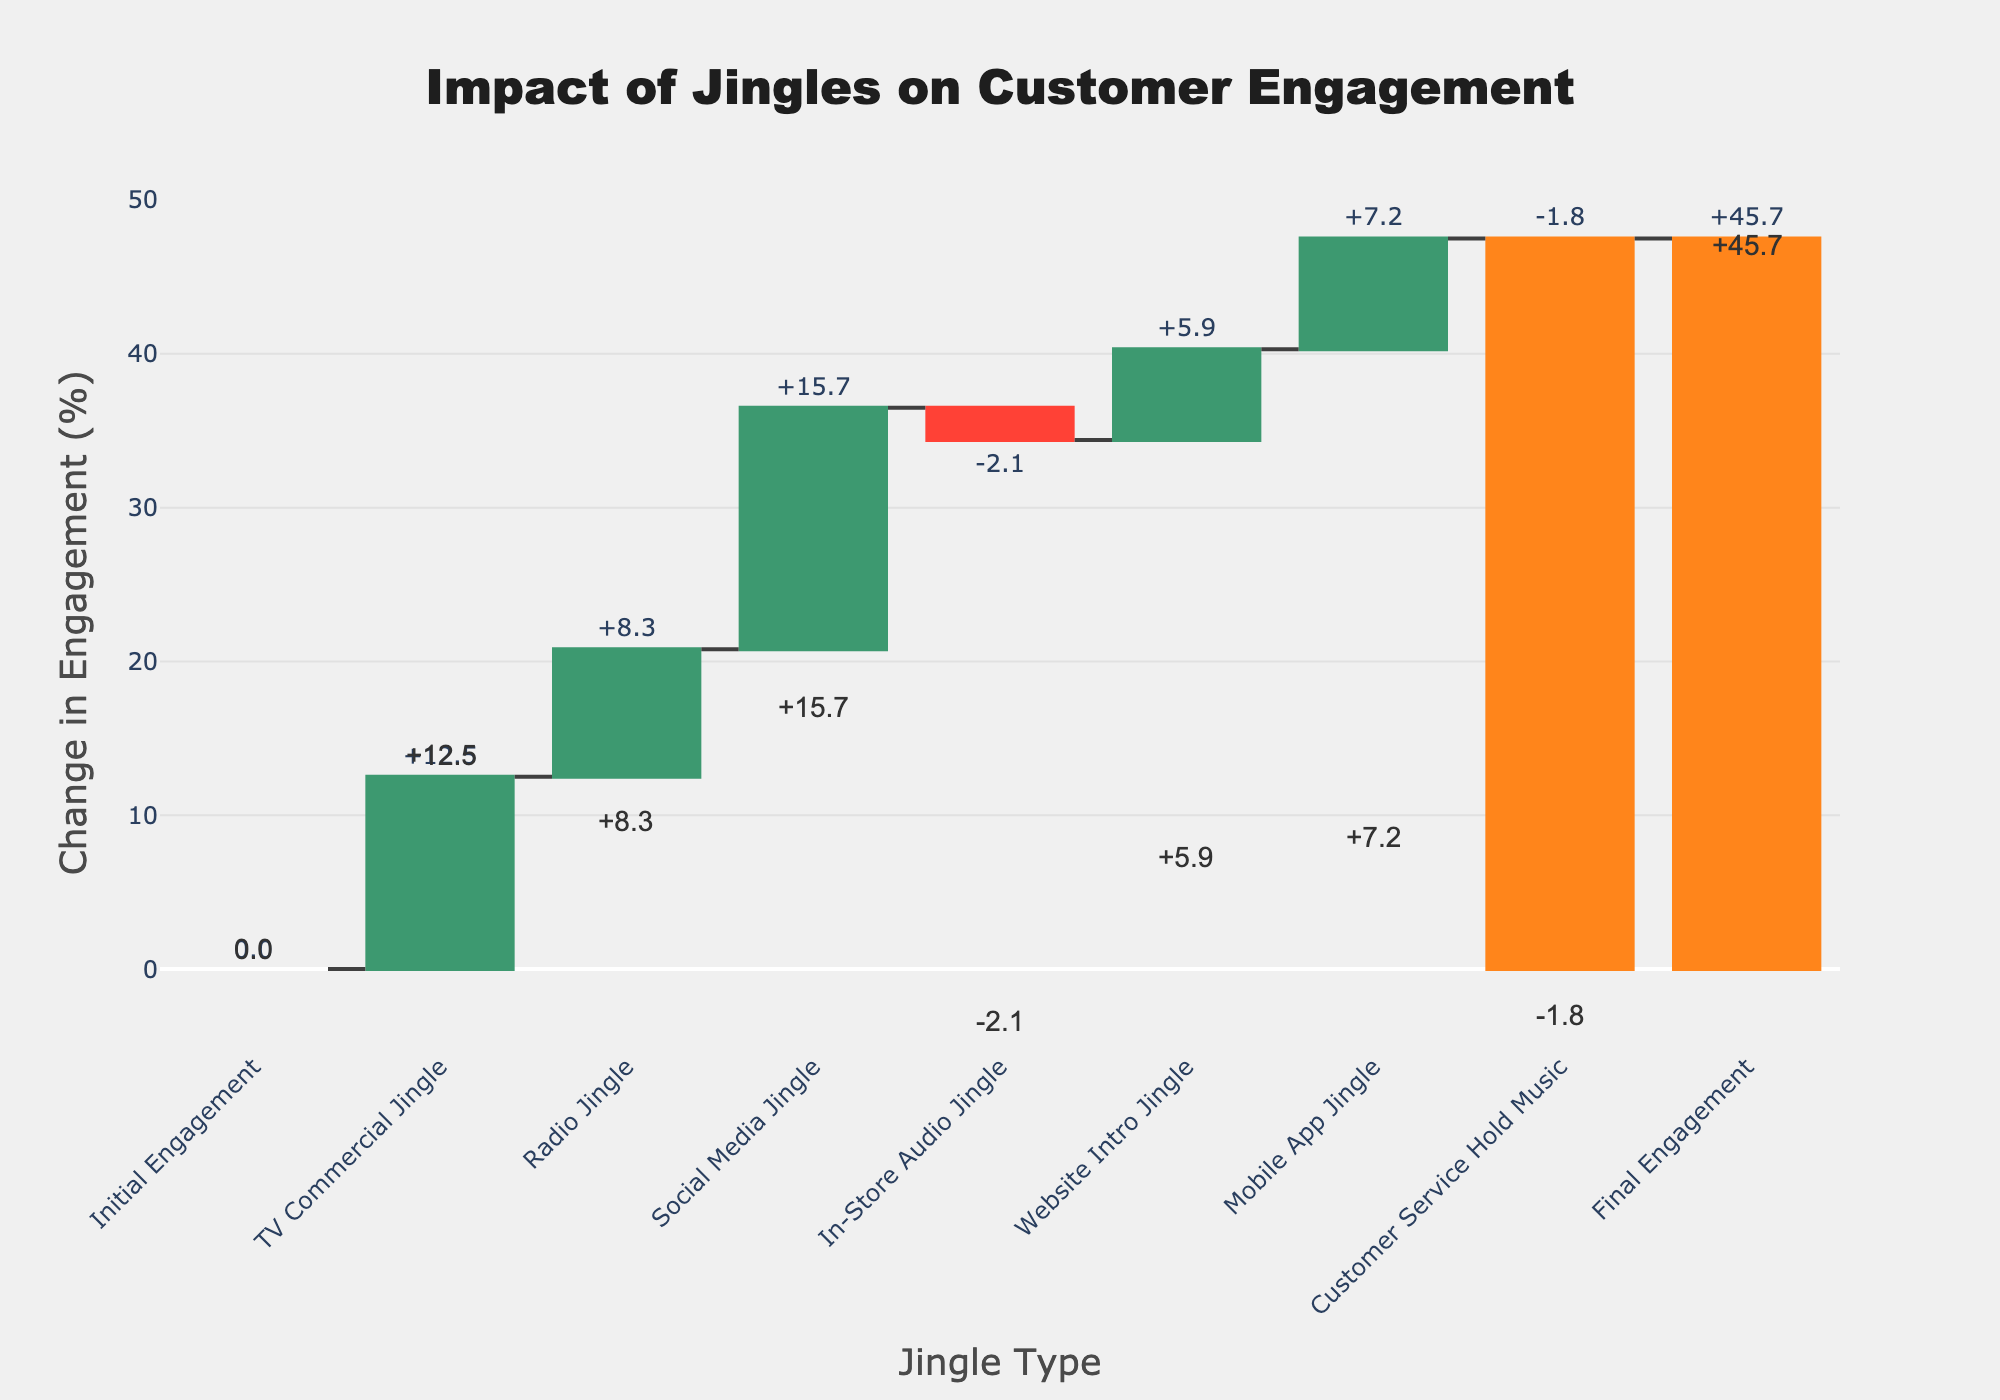What is the title of the chart? The chart's title is displayed prominently at the top. Read the text of the title to get the answer.
Answer: Impact of Jingles on Customer Engagement Which jingle resulted in the highest increase in customer engagement? Look at the positive changes in the engagement values for each jingle and identify the highest one. The 'Social Media Jingle' shows the highest increase of +15.7%.
Answer: Social Media Jingle What became of the overall customer engagement after the rollout of the jingles? Determine the "Final Engagement" value provided at the end of the chart. The "Final Engagement" is 45.7%.
Answer: 45.7% How much did the TV Commercial Jingle contribute to the change in customer engagement? The TV Commercial Jingle's contribution is explicitly labeled in the chart as +12.5%.
Answer: +12.5% How many jingles caused a decrease in customer engagement? Check the jingle entries with negative values. 'In-Store Audio Jingle' and 'Customer Service Hold Music' both have negative values, making a total of 2 jingles.
Answer: 2 What is the difference in engagement impact between the 'Radio Jingle' and 'Social Media Jingle'? Subtract the value of 'Radio Jingle' from 'Social Media Jingle' to get the difference: 15.7 - 8.3 = 7.4.
Answer: 7.4 Which jingles had a negative impact on customer engagement, and what are their values? Identify the jingles with negative values. 'In-Store Audio Jingle' has -2.1%, and 'Customer Service Hold Music' has -1.8%.
Answer: In-Store Audio Jingle (-2.1%), Customer Service Hold Music (-1.8%) How does the impact of 'Website Intro Jingle' compare to 'Mobile App Jingle'? Compare their values: 5.9% for 'Website Intro Jingle' and 7.2% for 'Mobile App Jingle'. 'Mobile App Jingle' has a greater impact.
Answer: Mobile App Jingle has a greater impact Calculate the total positive change in customer engagement from all jingles combined, except the 'Final Engagement'. Add all the positive changes together: 12.5 + 8.3 + 15.7 + 5.9 + 7.2 = 49.6%.
Answer: 49.6% What is the net change in customer engagement from 'In-Store Audio Jingle' and 'Customer Service Hold Music'? Add the negative values together: -2.1 + (-1.8) = -3.9%.
Answer: -3.9% 